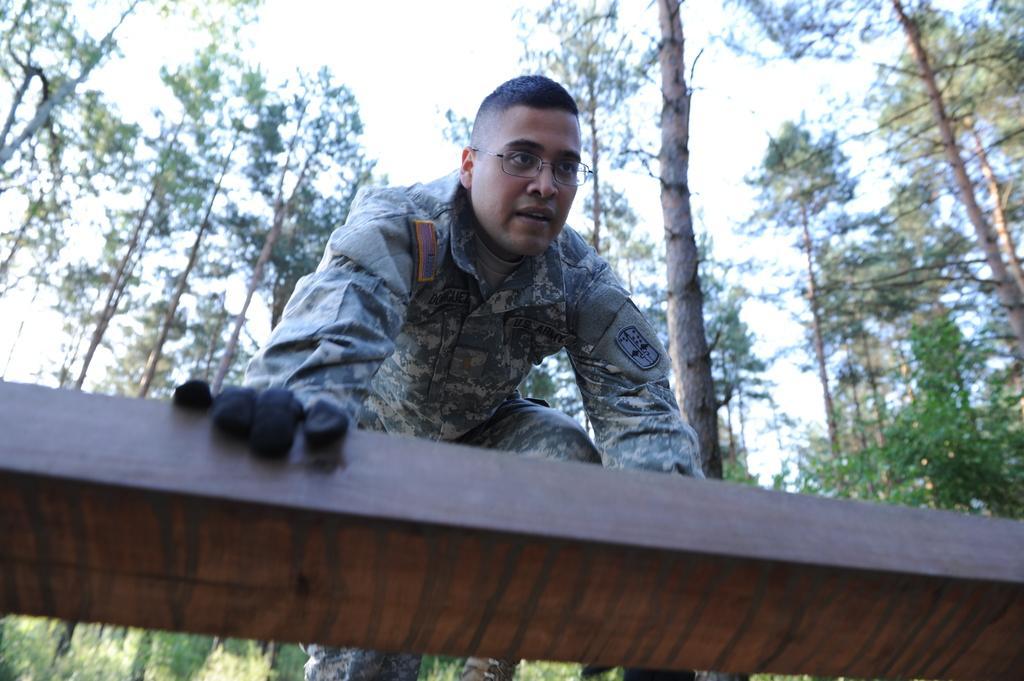Describe this image in one or two sentences. In the image in the center we can see one person standing and holding wood. In the background we can see the sky,clouds and trees. 